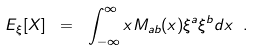<formula> <loc_0><loc_0><loc_500><loc_500>E _ { \xi } [ X ] \ = \ \int _ { - \infty } ^ { \infty } x M _ { a b } ( x ) \xi ^ { a } \xi ^ { b } d x \ .</formula> 